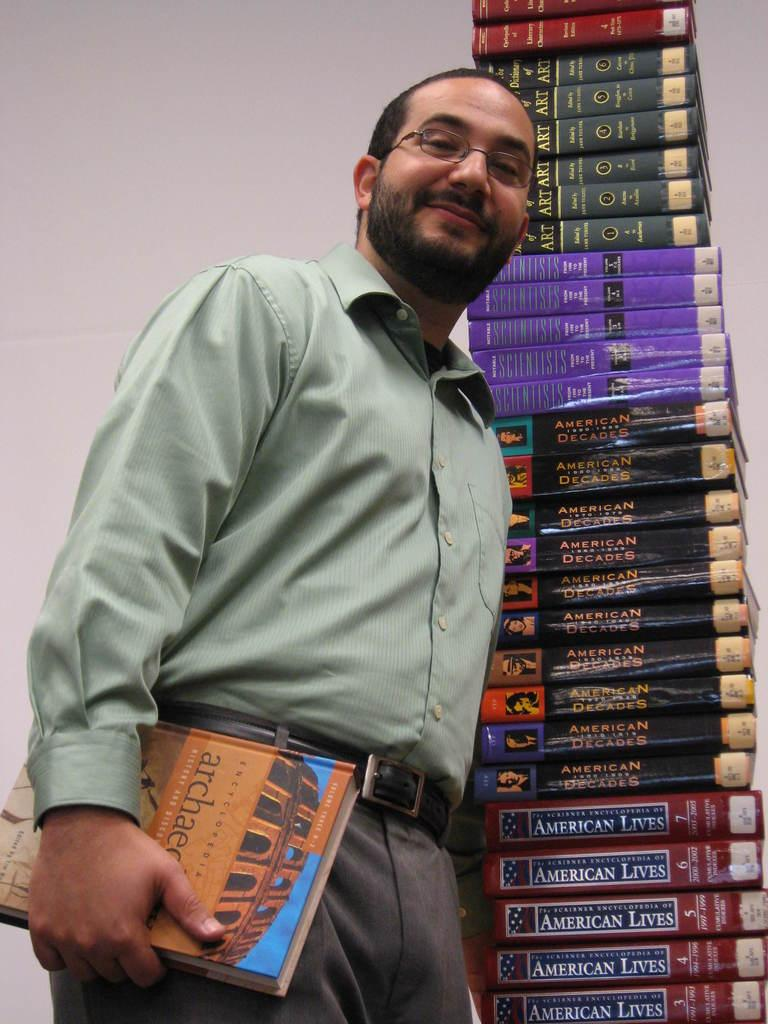<image>
Offer a succinct explanation of the picture presented. A man standing next to a stack of books about American history and other topics. 